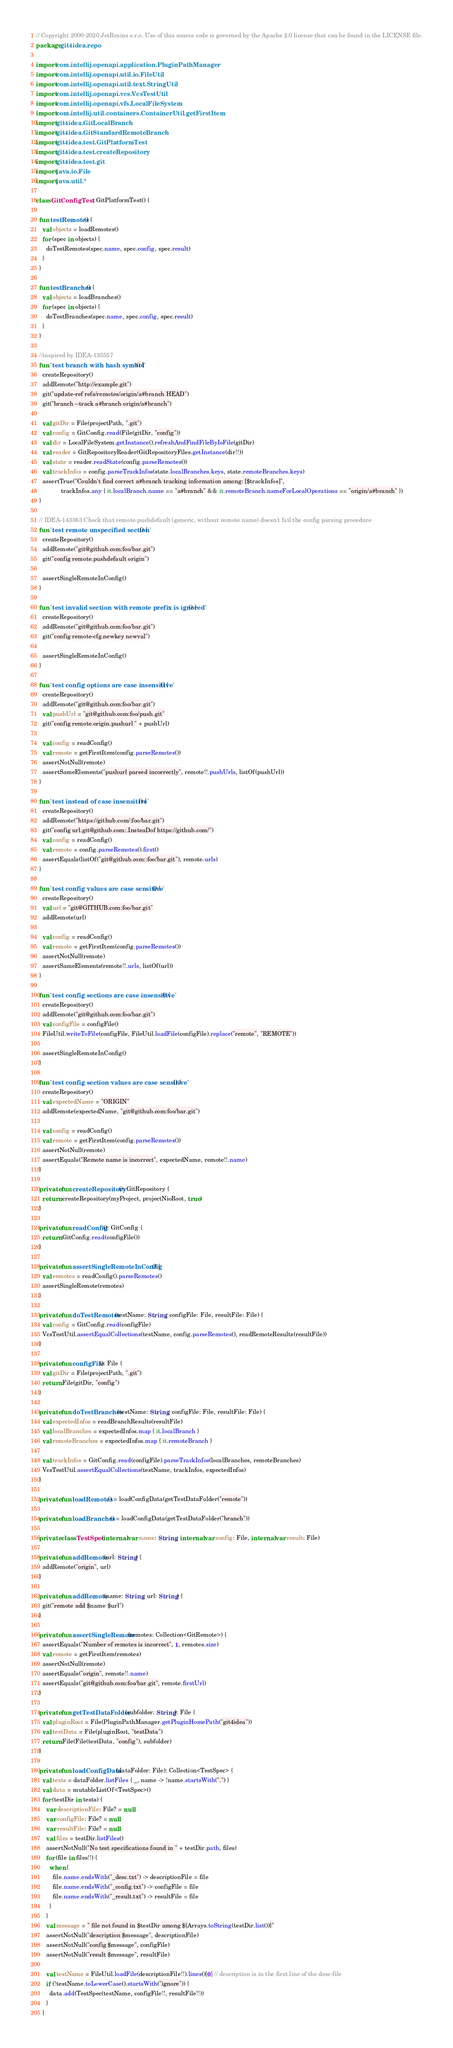Convert code to text. <code><loc_0><loc_0><loc_500><loc_500><_Kotlin_>// Copyright 2000-2020 JetBrains s.r.o. Use of this source code is governed by the Apache 2.0 license that can be found in the LICENSE file.
package git4idea.repo

import com.intellij.openapi.application.PluginPathManager
import com.intellij.openapi.util.io.FileUtil
import com.intellij.openapi.util.text.StringUtil
import com.intellij.openapi.vcs.VcsTestUtil
import com.intellij.openapi.vfs.LocalFileSystem
import com.intellij.util.containers.ContainerUtil.getFirstItem
import git4idea.GitLocalBranch
import git4idea.GitStandardRemoteBranch
import git4idea.test.GitPlatformTest
import git4idea.test.createRepository
import git4idea.test.git
import java.io.File
import java.util.*

class GitConfigTest : GitPlatformTest() {

  fun testRemotes() {
    val objects = loadRemotes()
    for (spec in objects) {
      doTestRemotes(spec.name, spec.config, spec.result)
    }
  }

  fun testBranches() {
    val objects = loadBranches()
    for (spec in objects) {
      doTestBranches(spec.name, spec.config, spec.result)
    }
  }

  //inspired by IDEA-135557
  fun `test branch with hash symbol`() {
    createRepository()
    addRemote("http://example.git")
    git("update-ref refs/remotes/origin/a#branch HEAD")
    git("branch --track a#branch origin/a#branch")

    val gitDir = File(projectPath, ".git")
    val config = GitConfig.read(File(gitDir, "config"))
    val dir = LocalFileSystem.getInstance().refreshAndFindFileByIoFile(gitDir)
    val reader = GitRepositoryReader(GitRepositoryFiles.getInstance(dir!!))
    val state = reader.readState(config.parseRemotes())
    val trackInfos = config.parseTrackInfos(state.localBranches.keys, state.remoteBranches.keys)
    assertTrue("Couldn't find correct a#branch tracking information among: [$trackInfos]",
               trackInfos.any { it.localBranch.name == "a#branch" && it.remoteBranch.nameForLocalOperations == "origin/a#branch" })
  }

  // IDEA-143363 Check that remote.pushdefault (generic, without remote name) doesn't fail the config parsing procedure
  fun `test remote unspecified section`() {
    createRepository()
    addRemote("git@github.com:foo/bar.git")
    git("config remote.pushdefault origin")

    assertSingleRemoteInConfig()
  }

  fun `test invalid section with remote prefix is ignored`() {
    createRepository()
    addRemote("git@github.com:foo/bar.git")
    git("config remote-cfg.newkey newval")

    assertSingleRemoteInConfig()
  }

  fun `test config options are case insensitive`() {
    createRepository()
    addRemote("git@github.com:foo/bar.git")
    val pushUrl = "git@github.com:foo/push.git"
    git("config remote.origin.pushurl " + pushUrl)

    val config = readConfig()
    val remote = getFirstItem(config.parseRemotes())
    assertNotNull(remote)
    assertSameElements("pushurl parsed incorrectly", remote!!.pushUrls, listOf(pushUrl))
  }

  fun `test instead of case insensitive`() {
    createRepository()
    addRemote("https://github.com/:foo/bar.git")
    git("config url.git@github.com:.InsteaDof https://github.com/")
    val config = readConfig()
    val remote = config.parseRemotes().first()
    assertEquals(listOf("git@github.com::foo/bar.git"), remote.urls)
  }

  fun `test config values are case sensitive`() {
    createRepository()
    val url = "git@GITHUB.com:foo/bar.git"
    addRemote(url)

    val config = readConfig()
    val remote = getFirstItem(config.parseRemotes())
    assertNotNull(remote)
    assertSameElements(remote!!.urls, listOf(url))
  }

  fun `test config sections are case insensitive`() {
    createRepository()
    addRemote("git@github.com:foo/bar.git")
    val configFile = configFile()
    FileUtil.writeToFile(configFile, FileUtil.loadFile(configFile).replace("remote", "REMOTE"))

    assertSingleRemoteInConfig()
  }

  fun `test config section values are case sensitive`() {
    createRepository()
    val expectedName = "ORIGIN"
    addRemote(expectedName, "git@github.com:foo/bar.git")

    val config = readConfig()
    val remote = getFirstItem(config.parseRemotes())
    assertNotNull(remote)
    assertEquals("Remote name is incorrect", expectedName, remote!!.name)
  }

  private fun createRepository(): GitRepository {
    return createRepository(myProject, projectNioRoot, true)
  }

  private fun readConfig(): GitConfig {
    return GitConfig.read(configFile())
  }

  private fun assertSingleRemoteInConfig() {
    val remotes = readConfig().parseRemotes()
    assertSingleRemote(remotes)
  }

  private fun doTestRemotes(testName: String, configFile: File, resultFile: File) {
    val config = GitConfig.read(configFile)
    VcsTestUtil.assertEqualCollections(testName, config.parseRemotes(), readRemoteResults(resultFile))
  }

  private fun configFile(): File {
    val gitDir = File(projectPath, ".git")
    return File(gitDir, "config")
  }

  private fun doTestBranches(testName: String, configFile: File, resultFile: File) {
    val expectedInfos = readBranchResults(resultFile)
    val localBranches = expectedInfos.map { it.localBranch }
    val remoteBranches = expectedInfos.map { it.remoteBranch }

    val trackInfos = GitConfig.read(configFile).parseTrackInfos(localBranches, remoteBranches)
    VcsTestUtil.assertEqualCollections(testName, trackInfos, expectedInfos)
  }

  private fun loadRemotes() = loadConfigData(getTestDataFolder("remote"))

  private fun loadBranches() = loadConfigData(getTestDataFolder("branch"))

  private class TestSpec(internal var name: String, internal var config: File, internal var result: File)

  private fun addRemote(url: String) {
    addRemote("origin", url)
  }

  private fun addRemote(name: String, url: String) {
    git("remote add $name $url")
  }

  private fun assertSingleRemote(remotes: Collection<GitRemote>) {
    assertEquals("Number of remotes is incorrect", 1, remotes.size)
    val remote = getFirstItem(remotes)
    assertNotNull(remote)
    assertEquals("origin", remote!!.name)
    assertEquals("git@github.com:foo/bar.git", remote.firstUrl)
  }

  private fun getTestDataFolder(subfolder: String): File {
    val pluginRoot = File(PluginPathManager.getPluginHomePath("git4idea"))
    val testData = File(pluginRoot, "testData")
    return File(File(testData, "config"), subfolder)
  }

  private fun loadConfigData(dataFolder: File): Collection<TestSpec> {
    val tests = dataFolder.listFiles { _, name -> !name.startsWith(".") }
    val data = mutableListOf<TestSpec>()
    for (testDir in tests) {
      var descriptionFile: File? = null
      var configFile: File? = null
      var resultFile: File? = null
      val files = testDir.listFiles()
      assertNotNull("No test specifications found in " + testDir.path, files)
      for (file in files!!) {
        when {
          file.name.endsWith("_desc.txt") -> descriptionFile = file
          file.name.endsWith("_config.txt") -> configFile = file
          file.name.endsWith("_result.txt") -> resultFile = file
        }
      }
      val message = " file not found in $testDir among ${Arrays.toString(testDir.list())}"
      assertNotNull("description $message", descriptionFile)
      assertNotNull("config $message", configFile)
      assertNotNull("result $message", resultFile)

      val testName = FileUtil.loadFile(descriptionFile!!).lines()[0] // description is in the first line of the desc-file
      if (!testName.toLowerCase().startsWith("ignore")) {
        data.add(TestSpec(testName, configFile!!, resultFile!!))
      }
    }</code> 